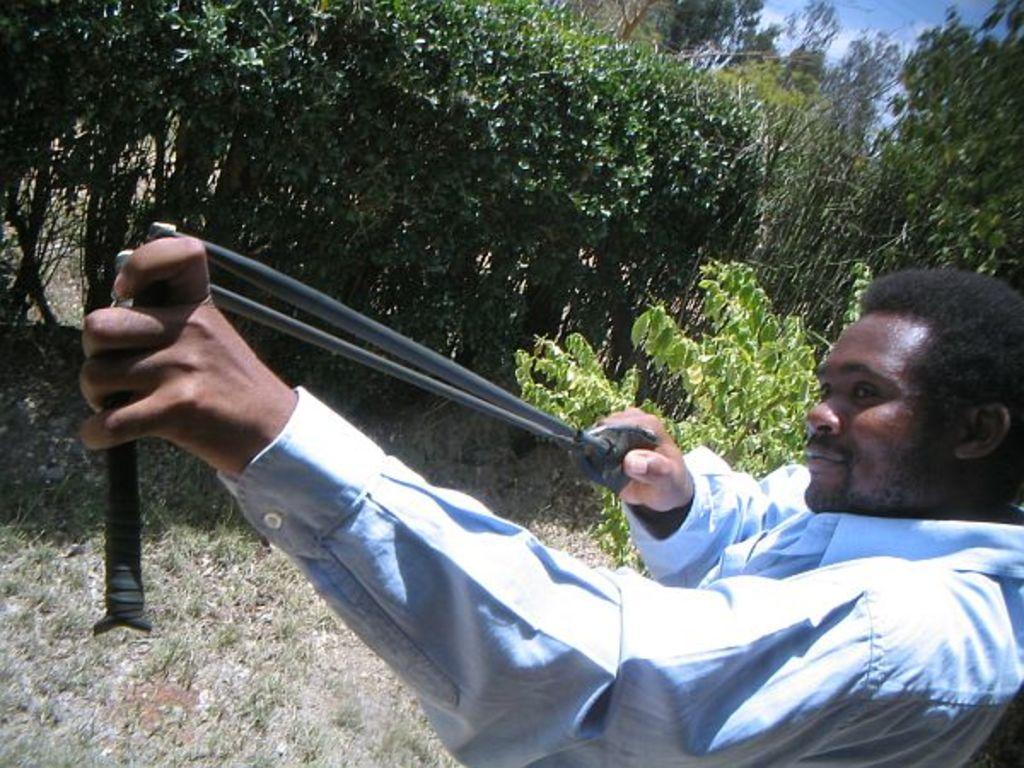How would you summarize this image in a sentence or two? In this image, on the right side, we can see a man holding an object in his two hands. In the background, we can see some trees and plants. At the top, we can see a sky, at the bottom, we can see a grass on the land. 